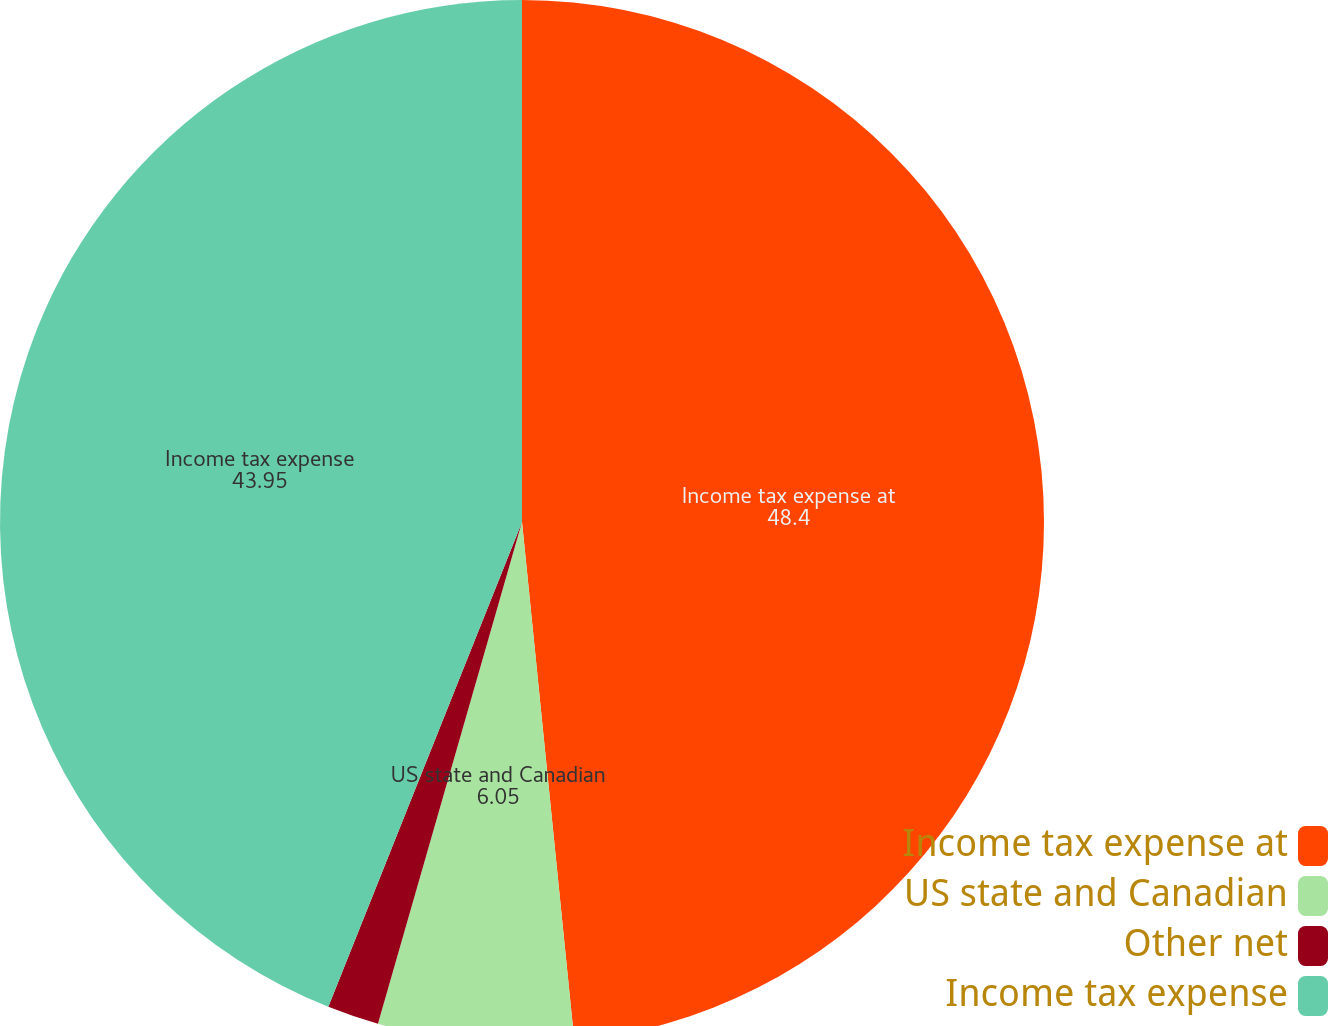Convert chart. <chart><loc_0><loc_0><loc_500><loc_500><pie_chart><fcel>Income tax expense at<fcel>US state and Canadian<fcel>Other net<fcel>Income tax expense<nl><fcel>48.4%<fcel>6.05%<fcel>1.6%<fcel>43.95%<nl></chart> 